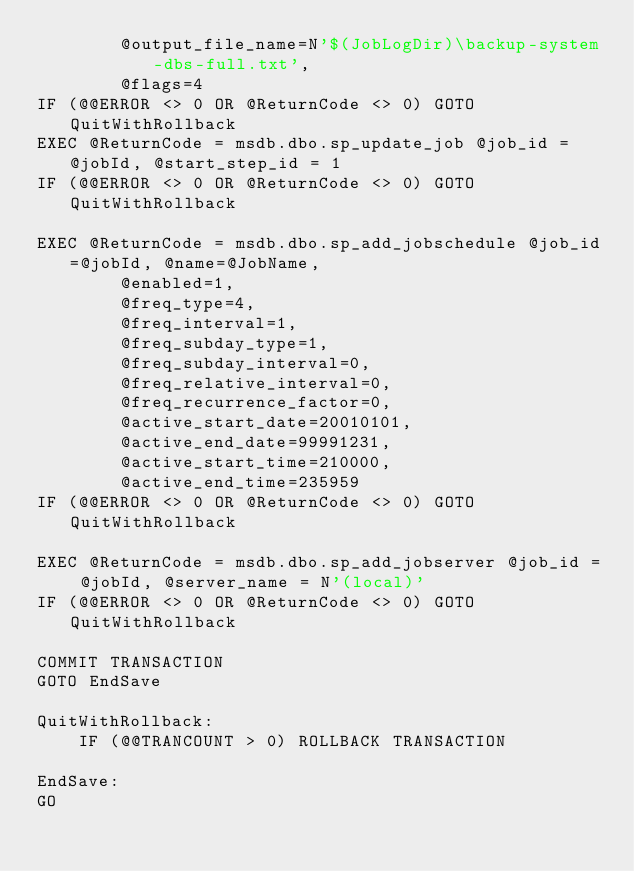<code> <loc_0><loc_0><loc_500><loc_500><_SQL_>		@output_file_name=N'$(JobLogDir)\backup-system-dbs-full.txt', 
		@flags=4
IF (@@ERROR <> 0 OR @ReturnCode <> 0) GOTO QuitWithRollback
EXEC @ReturnCode = msdb.dbo.sp_update_job @job_id = @jobId, @start_step_id = 1
IF (@@ERROR <> 0 OR @ReturnCode <> 0) GOTO QuitWithRollback

EXEC @ReturnCode = msdb.dbo.sp_add_jobschedule @job_id=@jobId, @name=@JobName, 
		@enabled=1, 
		@freq_type=4, 
		@freq_interval=1, 
		@freq_subday_type=1, 
		@freq_subday_interval=0, 
		@freq_relative_interval=0, 
		@freq_recurrence_factor=0, 
		@active_start_date=20010101, 
		@active_end_date=99991231, 
		@active_start_time=210000, 
		@active_end_time=235959 
IF (@@ERROR <> 0 OR @ReturnCode <> 0) GOTO QuitWithRollback

EXEC @ReturnCode = msdb.dbo.sp_add_jobserver @job_id = @jobId, @server_name = N'(local)'
IF (@@ERROR <> 0 OR @ReturnCode <> 0) GOTO QuitWithRollback

COMMIT TRANSACTION
GOTO EndSave

QuitWithRollback:
    IF (@@TRANCOUNT > 0) ROLLBACK TRANSACTION

EndSave:
GO</code> 